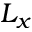<formula> <loc_0><loc_0><loc_500><loc_500>L _ { x }</formula> 